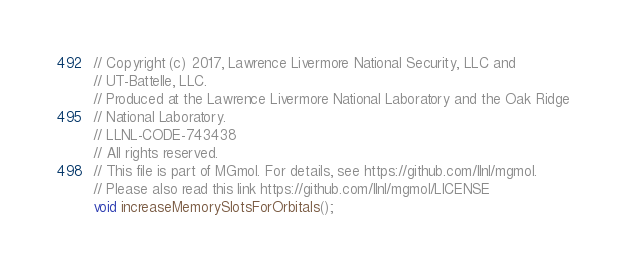Convert code to text. <code><loc_0><loc_0><loc_500><loc_500><_C_>// Copyright (c) 2017, Lawrence Livermore National Security, LLC and
// UT-Battelle, LLC.
// Produced at the Lawrence Livermore National Laboratory and the Oak Ridge
// National Laboratory.
// LLNL-CODE-743438
// All rights reserved.
// This file is part of MGmol. For details, see https://github.com/llnl/mgmol.
// Please also read this link https://github.com/llnl/mgmol/LICENSE
void increaseMemorySlotsForOrbitals();
</code> 